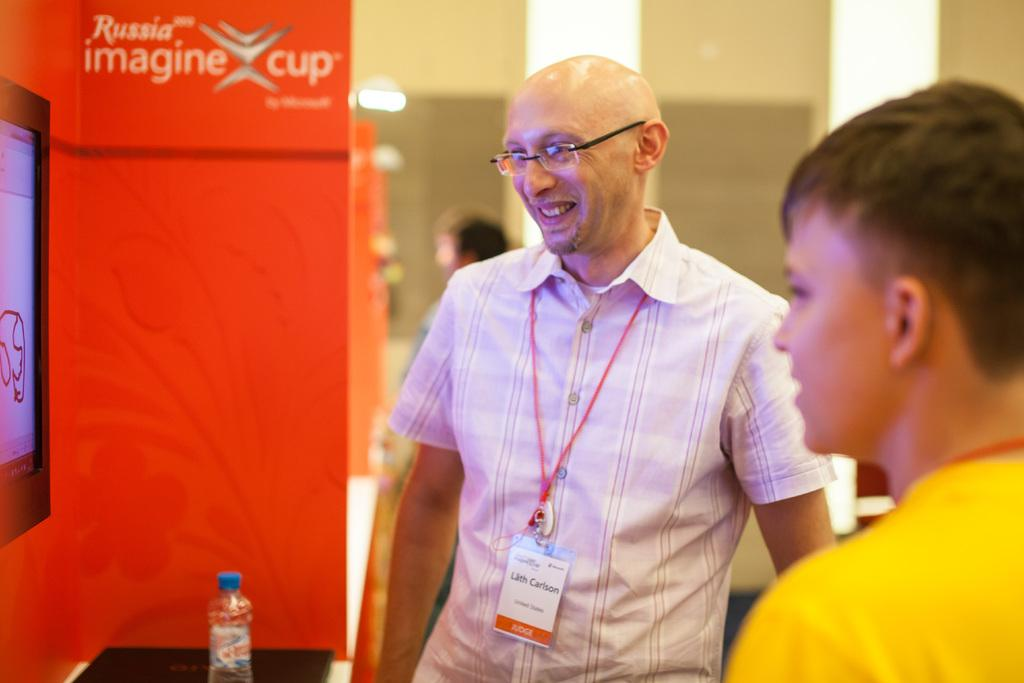How many people are present in the image? A: There are three people in the image. Can you describe the appearance of one of the men? One man is wearing an ID card and spectacles. What is the man's facial expression? The man is smiling. What can be seen on the left side of the image? There is a television and a bottle on the left side of the image. What type of whip is being used to prepare the cake in the image? There is no whip or cake present in the image. What type of meat is being cooked on the television in the image? There is no meat or cooking activity depicted on the television in the image. 